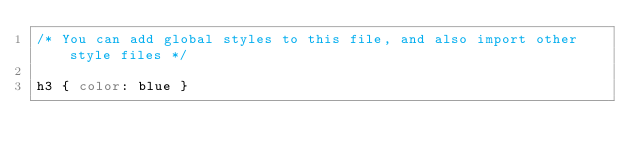Convert code to text. <code><loc_0><loc_0><loc_500><loc_500><_CSS_>/* You can add global styles to this file, and also import other style files */

h3 { color: blue }</code> 